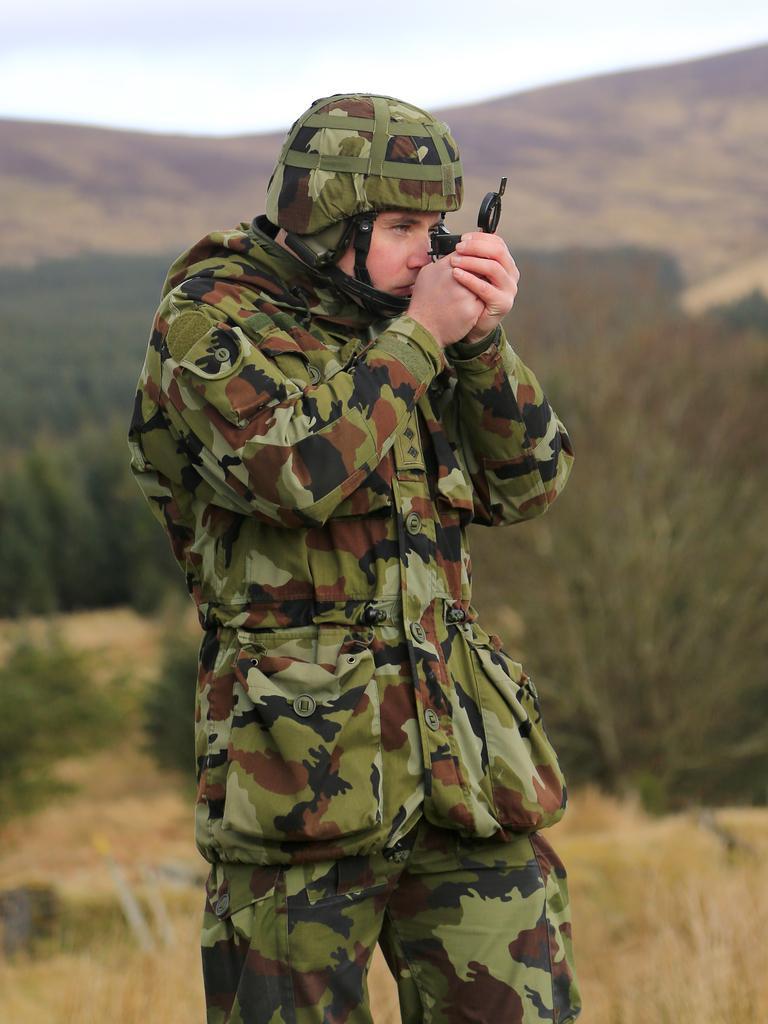Please provide a concise description of this image. In the foreground of this image, there is a man in military dress wearing a helmet on his head and holding a scope like an object in his hand. In the background, there is a grass, trees, mountains, sky and the cloud. 